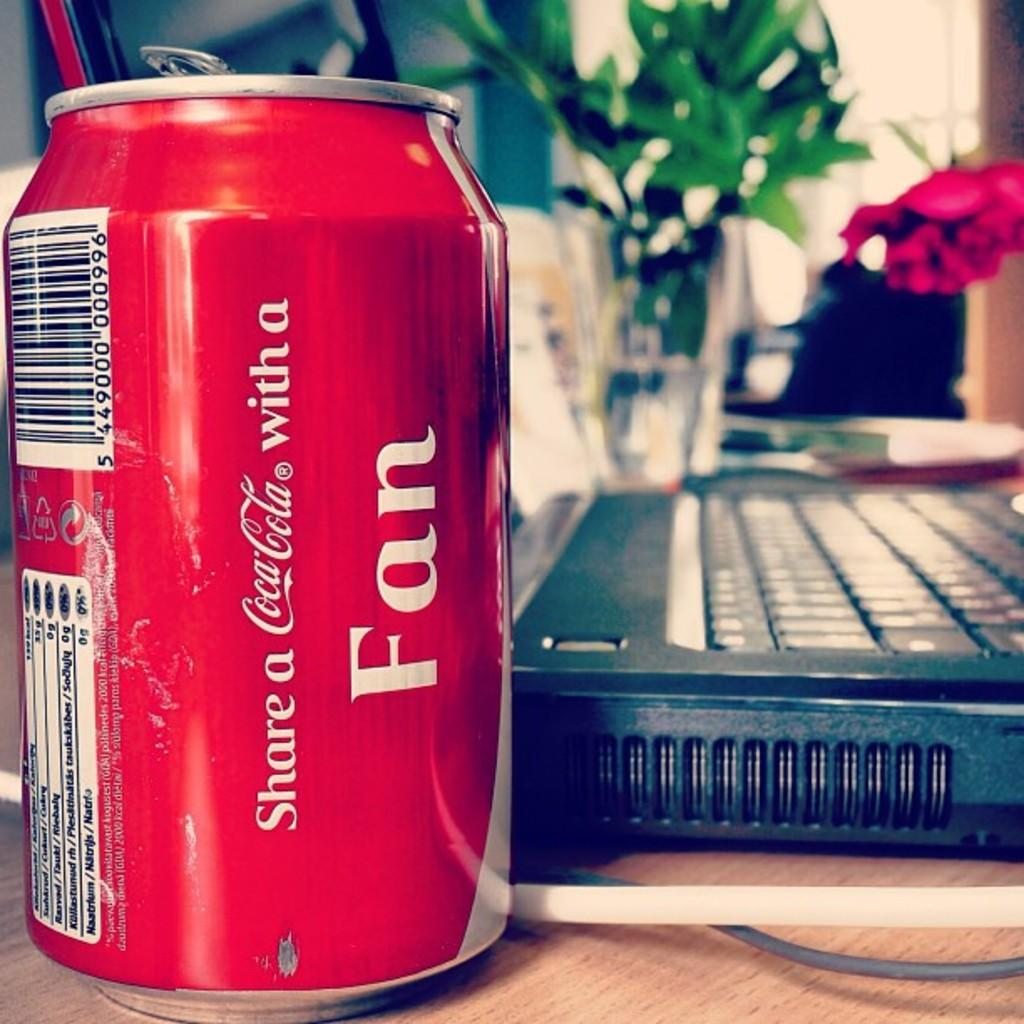<image>
Present a compact description of the photo's key features. The Coca Cola can has words on it that suggests you share it with a fan. 